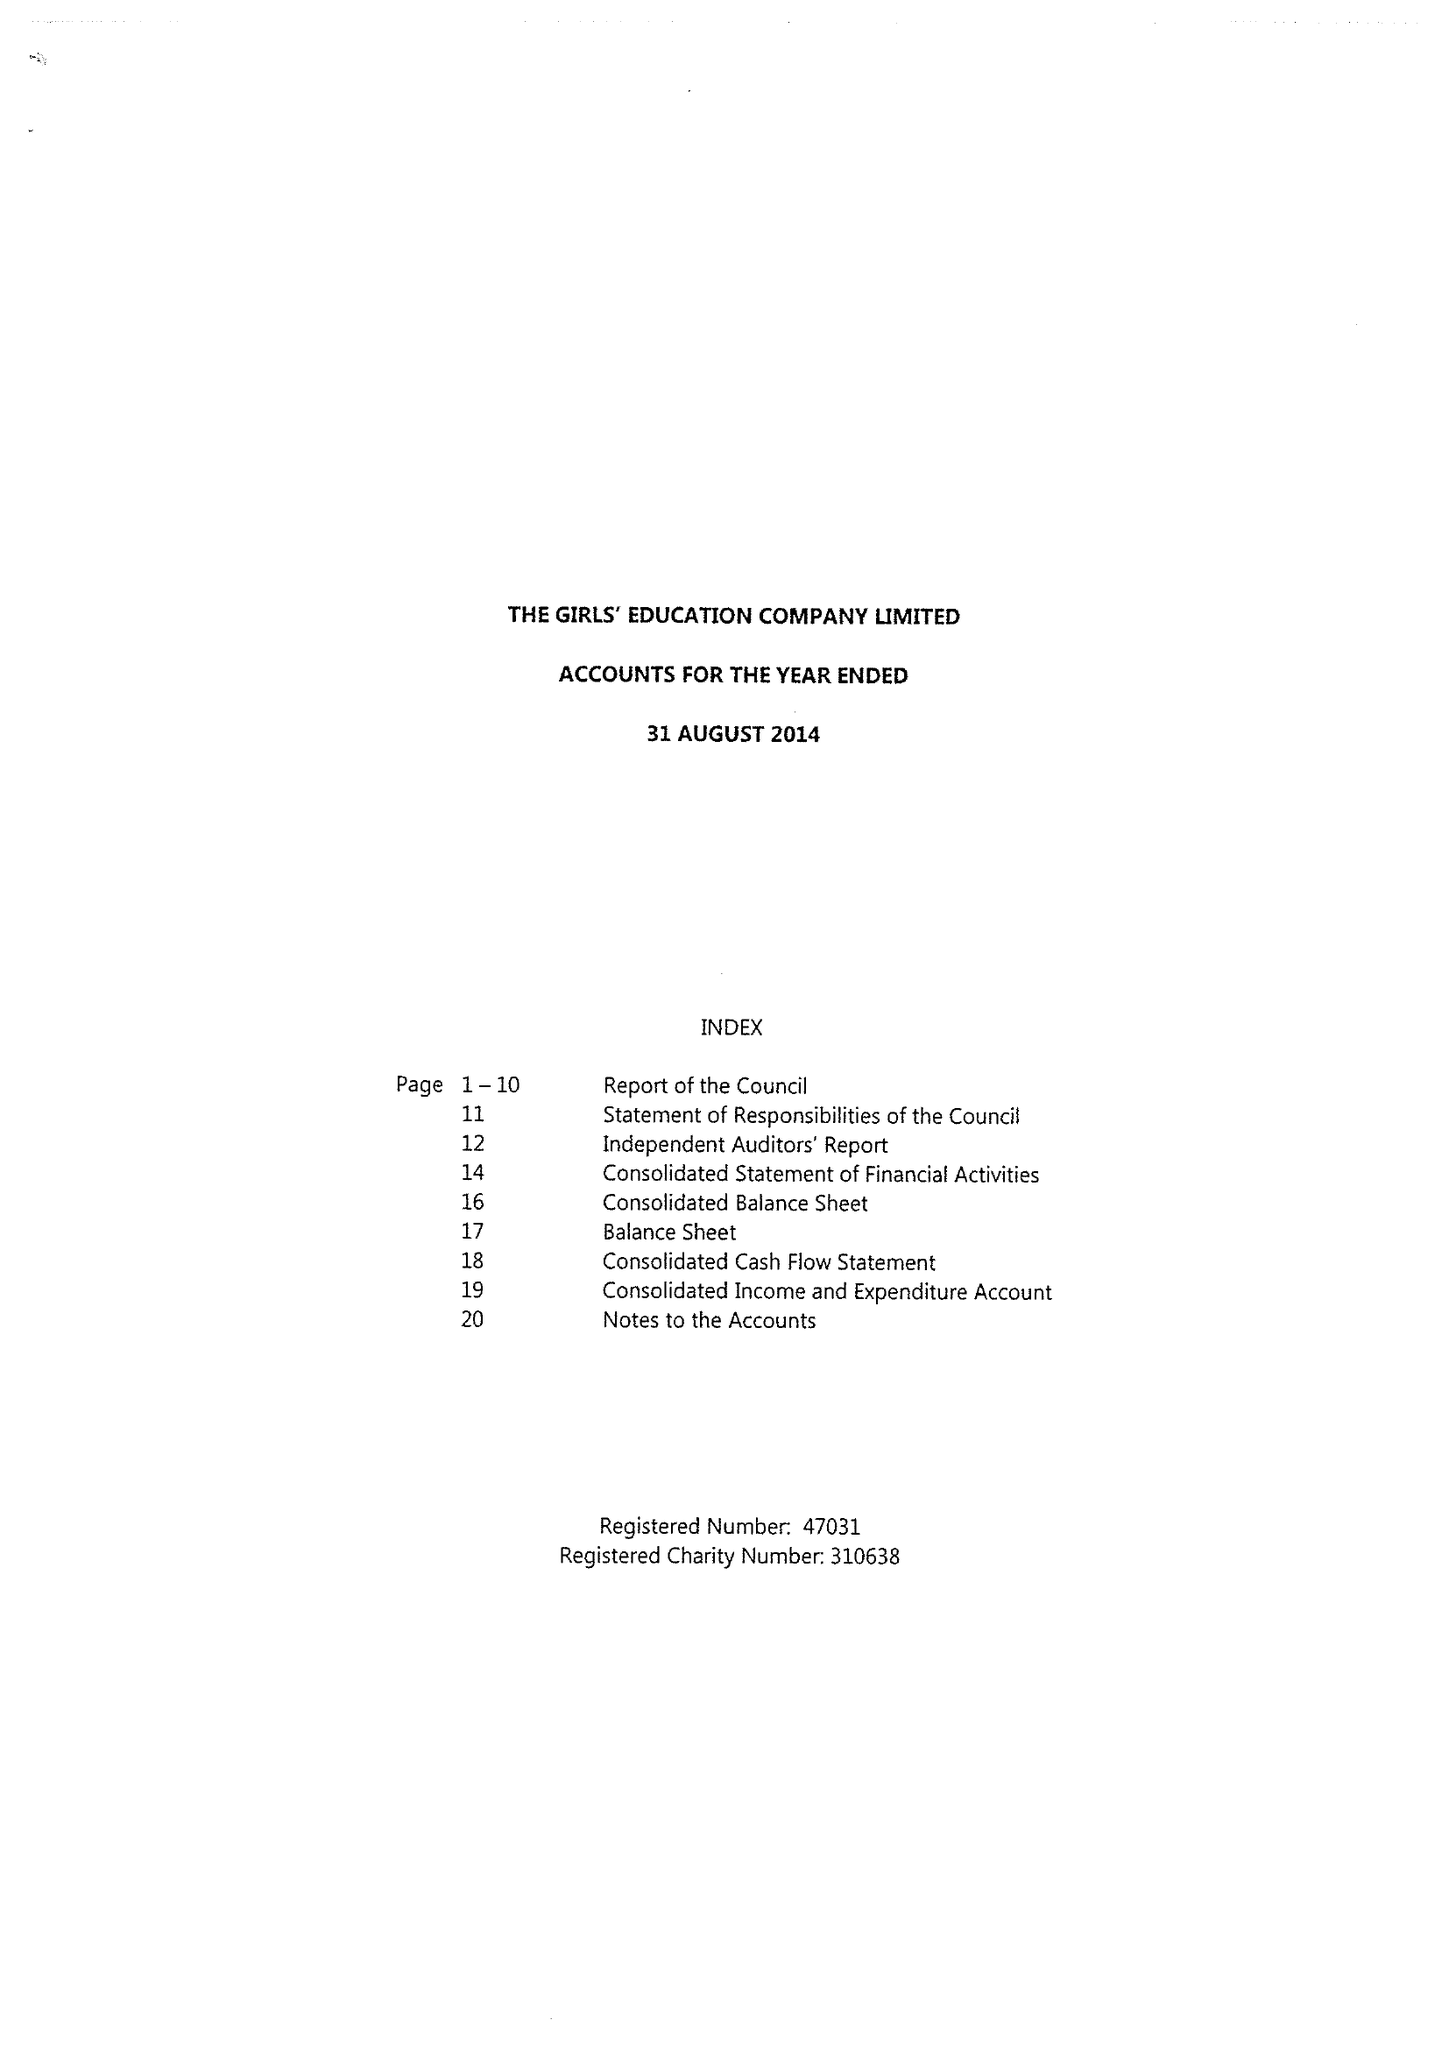What is the value for the charity_number?
Answer the question using a single word or phrase. 310638 